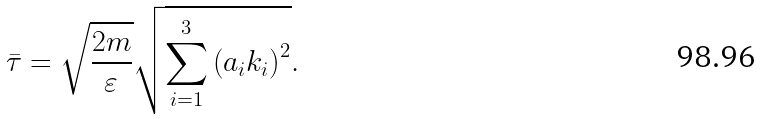Convert formula to latex. <formula><loc_0><loc_0><loc_500><loc_500>\bar { \tau } = \sqrt { \frac { 2 m } { \varepsilon } } \sqrt { \sum _ { i = 1 } ^ { 3 } \left ( a _ { i } k _ { i } \right ) ^ { 2 } } .</formula> 